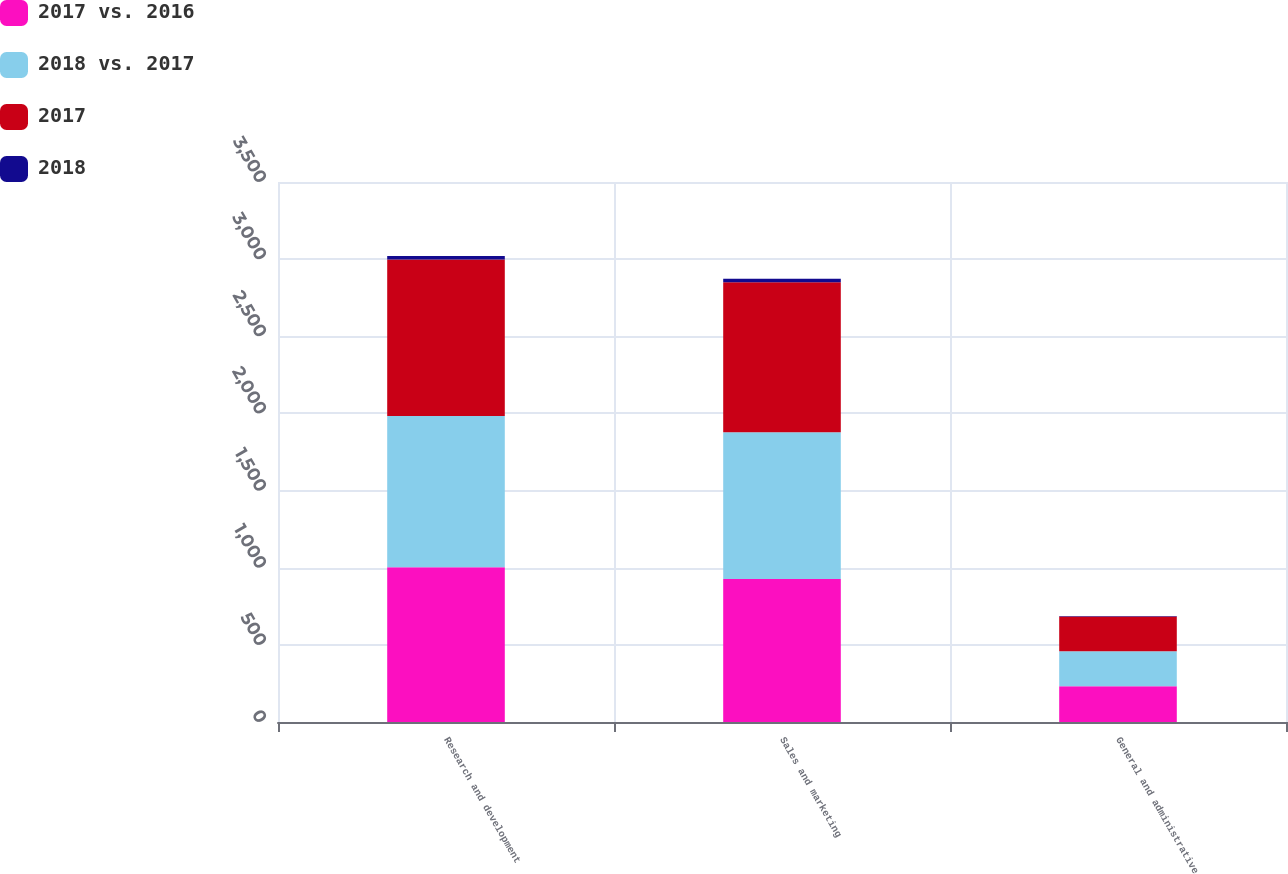Convert chart. <chart><loc_0><loc_0><loc_500><loc_500><stacked_bar_chart><ecel><fcel>Research and development<fcel>Sales and marketing<fcel>General and administrative<nl><fcel>2017 vs. 2016<fcel>1003.2<fcel>927.4<fcel>231.1<nl><fcel>2018 vs. 2017<fcel>980.7<fcel>950.2<fcel>227.5<nl><fcel>2017<fcel>1013.7<fcel>972.9<fcel>224.9<nl><fcel>2018<fcel>22.5<fcel>22.8<fcel>3.6<nl></chart> 